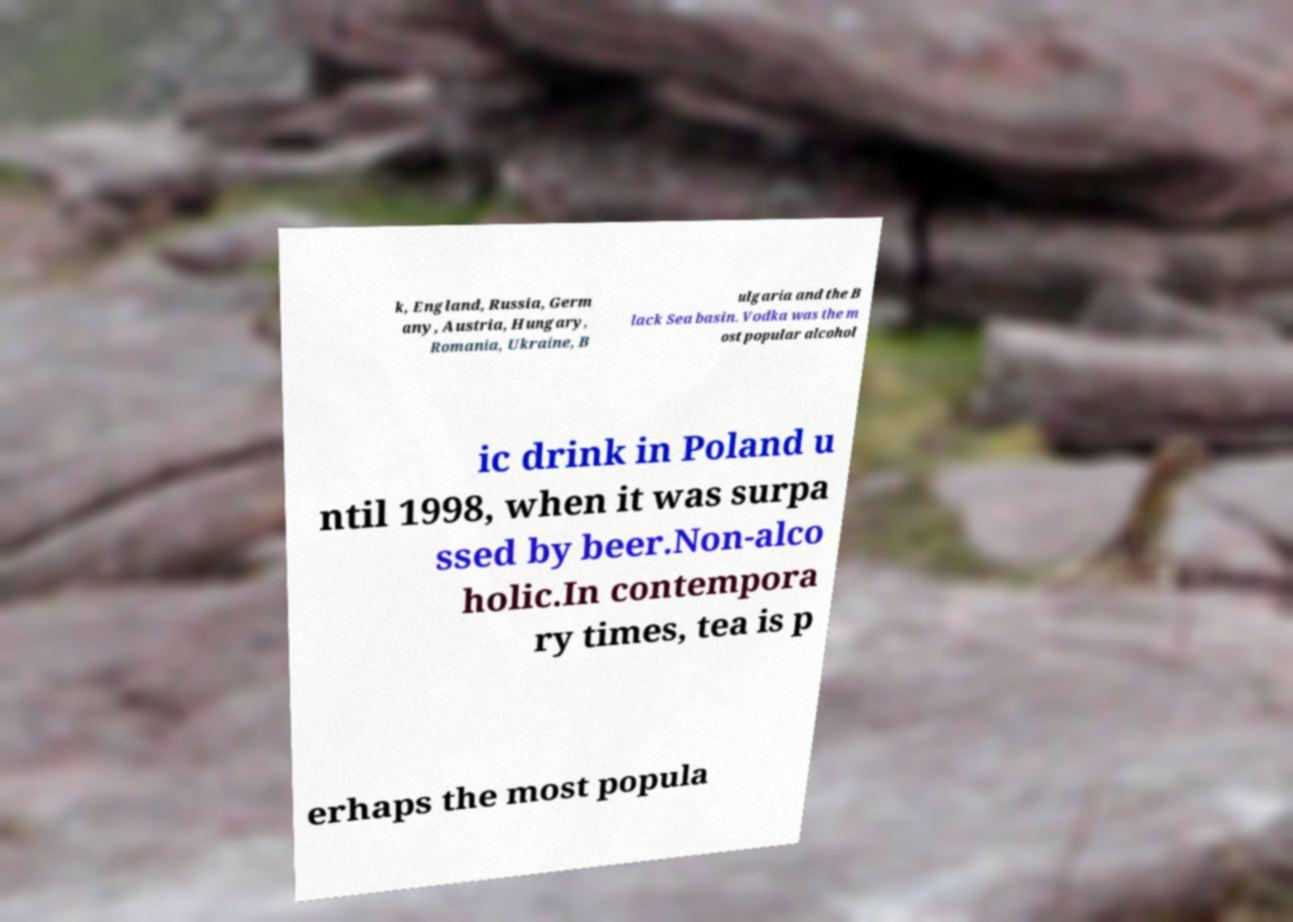Please read and relay the text visible in this image. What does it say? k, England, Russia, Germ any, Austria, Hungary, Romania, Ukraine, B ulgaria and the B lack Sea basin. Vodka was the m ost popular alcohol ic drink in Poland u ntil 1998, when it was surpa ssed by beer.Non-alco holic.In contempora ry times, tea is p erhaps the most popula 